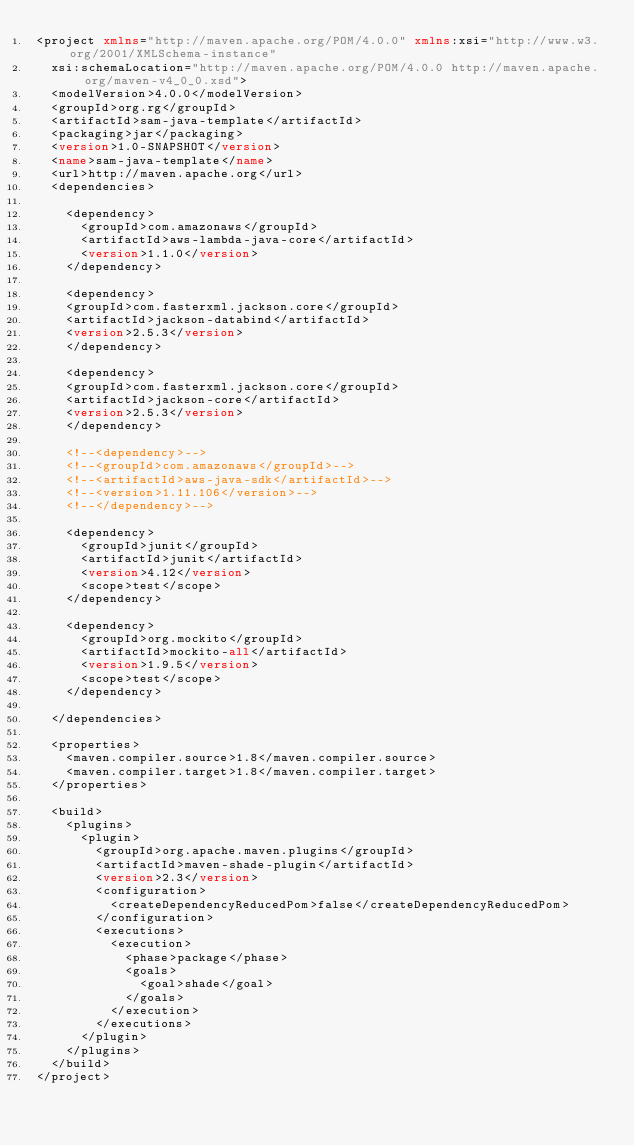<code> <loc_0><loc_0><loc_500><loc_500><_XML_><project xmlns="http://maven.apache.org/POM/4.0.0" xmlns:xsi="http://www.w3.org/2001/XMLSchema-instance"
  xsi:schemaLocation="http://maven.apache.org/POM/4.0.0 http://maven.apache.org/maven-v4_0_0.xsd">
  <modelVersion>4.0.0</modelVersion>
  <groupId>org.rg</groupId>
  <artifactId>sam-java-template</artifactId>
  <packaging>jar</packaging>
  <version>1.0-SNAPSHOT</version>
  <name>sam-java-template</name>
  <url>http://maven.apache.org</url>
  <dependencies>

    <dependency>
      <groupId>com.amazonaws</groupId>
      <artifactId>aws-lambda-java-core</artifactId>
      <version>1.1.0</version>
    </dependency>

    <dependency>
    <groupId>com.fasterxml.jackson.core</groupId>
    <artifactId>jackson-databind</artifactId>
    <version>2.5.3</version>
    </dependency>

    <dependency>
    <groupId>com.fasterxml.jackson.core</groupId>
    <artifactId>jackson-core</artifactId>
    <version>2.5.3</version>
    </dependency>

    <!--<dependency>-->
    <!--<groupId>com.amazonaws</groupId>-->
    <!--<artifactId>aws-java-sdk</artifactId>-->
    <!--<version>1.11.106</version>-->
    <!--</dependency>-->

    <dependency>
      <groupId>junit</groupId>
      <artifactId>junit</artifactId>
      <version>4.12</version>
      <scope>test</scope>
    </dependency>

    <dependency>
      <groupId>org.mockito</groupId>
      <artifactId>mockito-all</artifactId>
      <version>1.9.5</version>
      <scope>test</scope>
    </dependency>

  </dependencies>

  <properties>
    <maven.compiler.source>1.8</maven.compiler.source>
    <maven.compiler.target>1.8</maven.compiler.target>
  </properties>

  <build>
    <plugins>
      <plugin>
        <groupId>org.apache.maven.plugins</groupId>
        <artifactId>maven-shade-plugin</artifactId>
        <version>2.3</version>
        <configuration>
          <createDependencyReducedPom>false</createDependencyReducedPom>
        </configuration>
        <executions>
          <execution>
            <phase>package</phase>
            <goals>
              <goal>shade</goal>
            </goals>
          </execution>
        </executions>
      </plugin>
    </plugins>
  </build>
</project>
</code> 